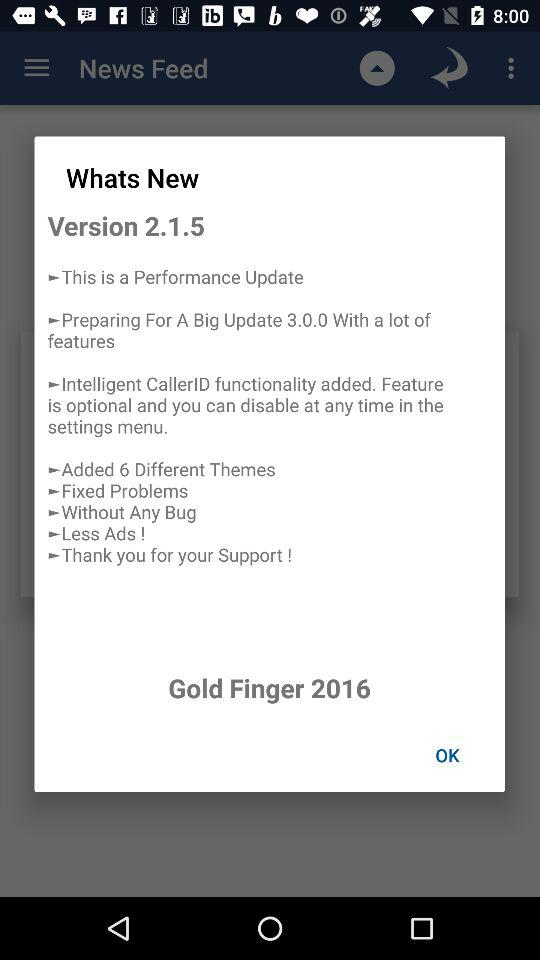Which version is used? The used version is 2.1.5. 